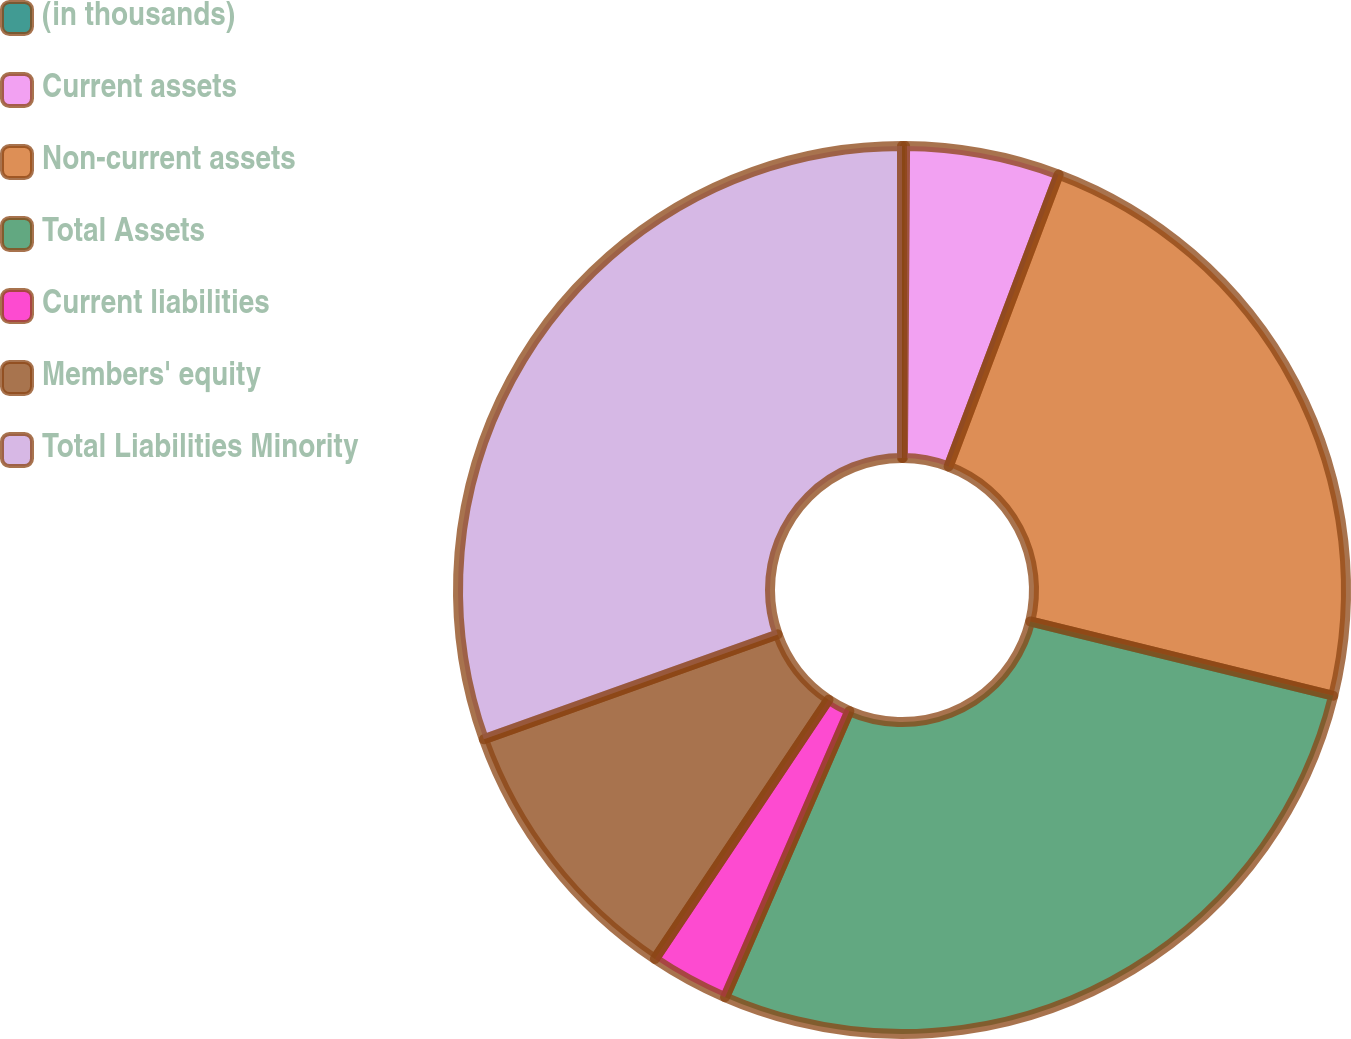Convert chart to OTSL. <chart><loc_0><loc_0><loc_500><loc_500><pie_chart><fcel>(in thousands)<fcel>Current assets<fcel>Non-current assets<fcel>Total Assets<fcel>Current liabilities<fcel>Members' equity<fcel>Total Liabilities Minority<nl><fcel>0.11%<fcel>5.63%<fcel>23.09%<fcel>27.7%<fcel>2.87%<fcel>10.15%<fcel>30.46%<nl></chart> 